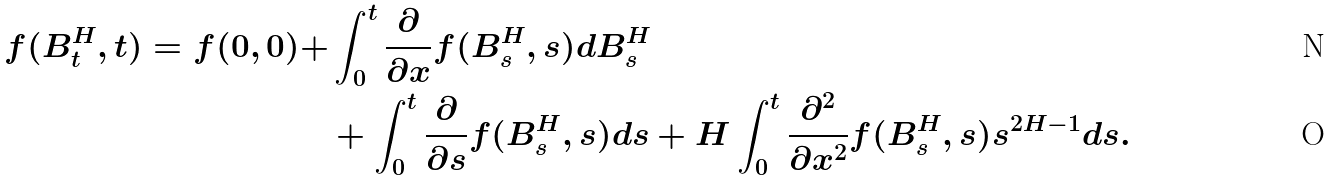<formula> <loc_0><loc_0><loc_500><loc_500>f ( B _ { t } ^ { H } , t ) = f ( 0 , 0 ) + & \int _ { 0 } ^ { t } \frac { \partial } { \partial x } f ( B _ { s } ^ { H } , s ) d B _ { s } ^ { H } \\ & + \int _ { 0 } ^ { t } \frac { \partial } { \partial s } f ( B _ { s } ^ { H } , s ) d s + H \int _ { 0 } ^ { t } \frac { \partial ^ { 2 } } { \partial x ^ { 2 } } f ( B _ { s } ^ { H } , s ) s ^ { 2 H - 1 } d s .</formula> 